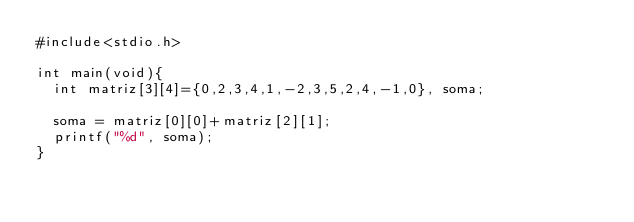Convert code to text. <code><loc_0><loc_0><loc_500><loc_500><_C++_>#include<stdio.h>

int main(void){
	int matriz[3][4]={0,2,3,4,1,-2,3,5,2,4,-1,0}, soma;
	
	soma = matriz[0][0]+matriz[2][1];
	printf("%d", soma);
}
</code> 